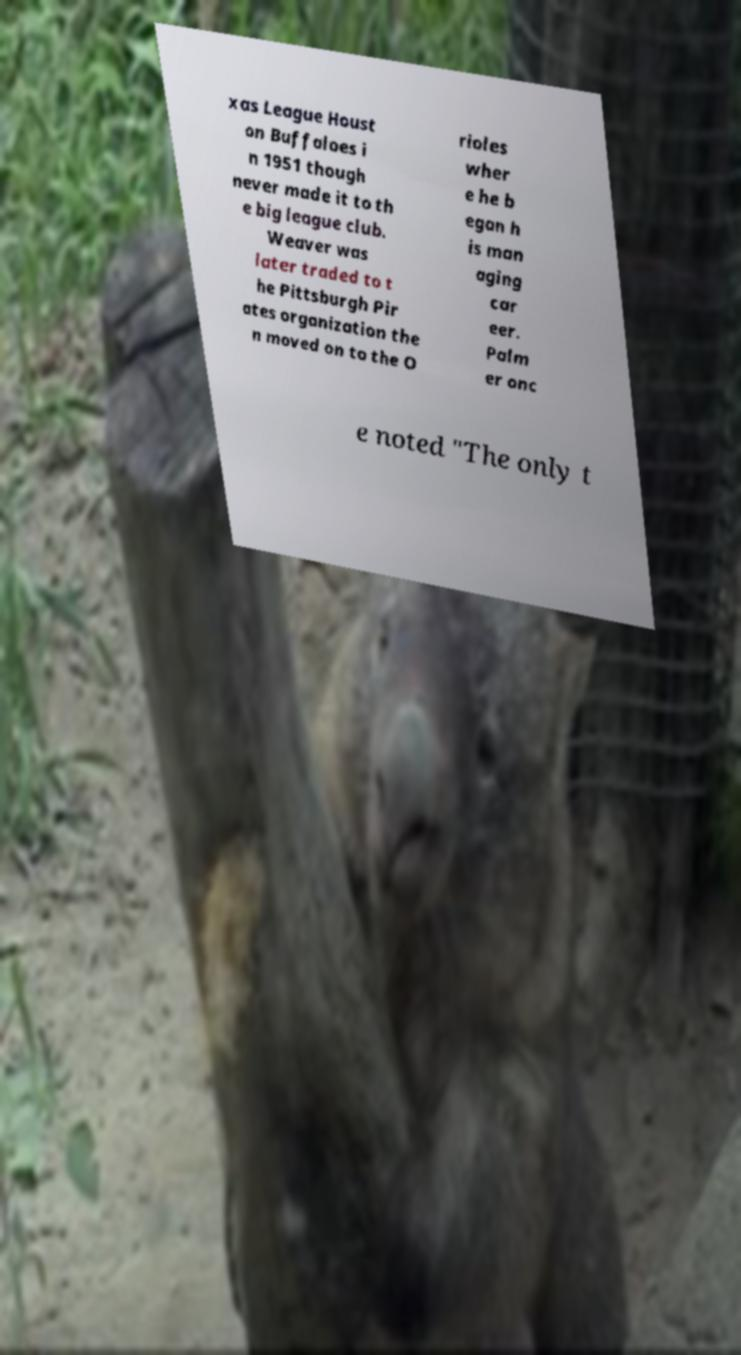Please identify and transcribe the text found in this image. xas League Houst on Buffaloes i n 1951 though never made it to th e big league club. Weaver was later traded to t he Pittsburgh Pir ates organization the n moved on to the O rioles wher e he b egan h is man aging car eer. Palm er onc e noted "The only t 